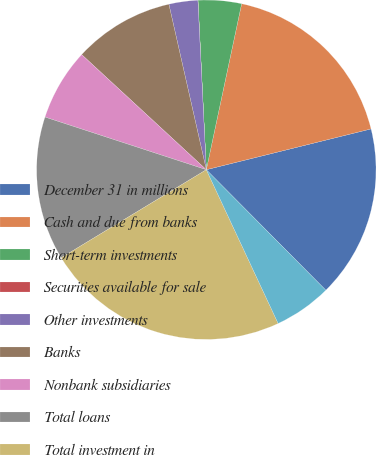Convert chart to OTSL. <chart><loc_0><loc_0><loc_500><loc_500><pie_chart><fcel>December 31 in millions<fcel>Cash and due from banks<fcel>Short-term investments<fcel>Securities available for sale<fcel>Other investments<fcel>Banks<fcel>Nonbank subsidiaries<fcel>Total loans<fcel>Total investment in<fcel>Goodwill<nl><fcel>16.43%<fcel>17.8%<fcel>4.12%<fcel>0.01%<fcel>2.75%<fcel>9.59%<fcel>6.85%<fcel>13.7%<fcel>23.28%<fcel>5.48%<nl></chart> 